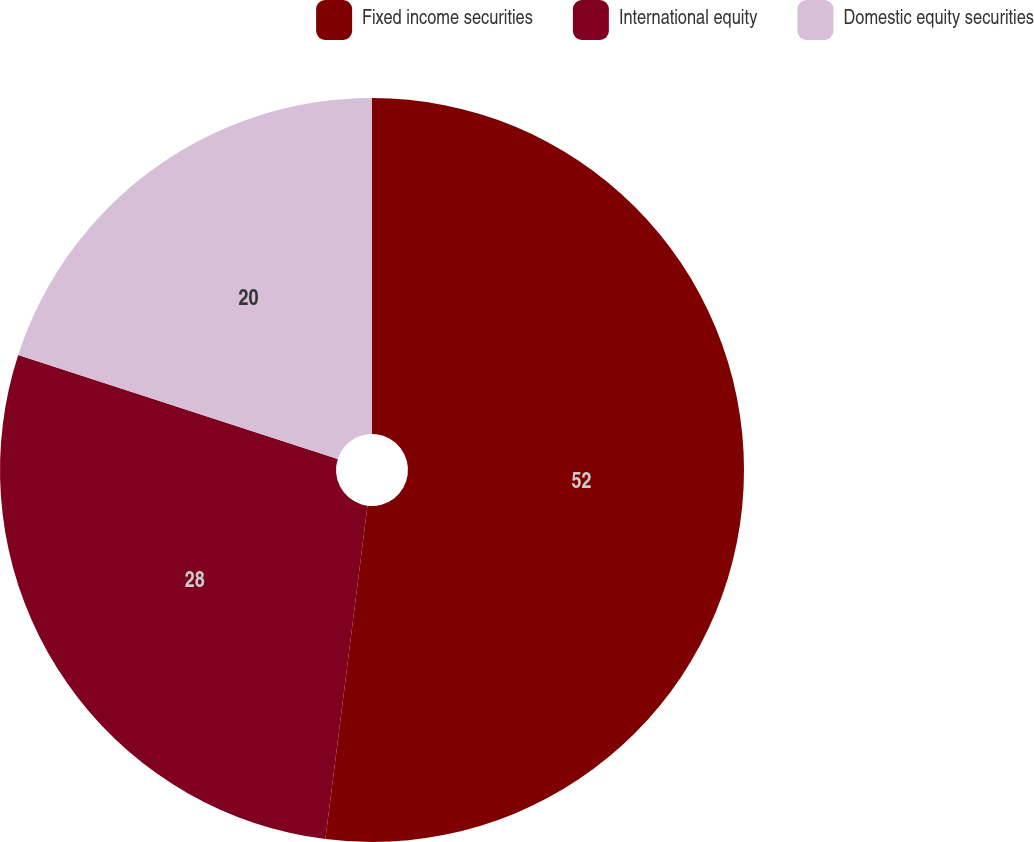Convert chart to OTSL. <chart><loc_0><loc_0><loc_500><loc_500><pie_chart><fcel>Fixed income securities<fcel>International equity<fcel>Domestic equity securities<nl><fcel>52.0%<fcel>28.0%<fcel>20.0%<nl></chart> 